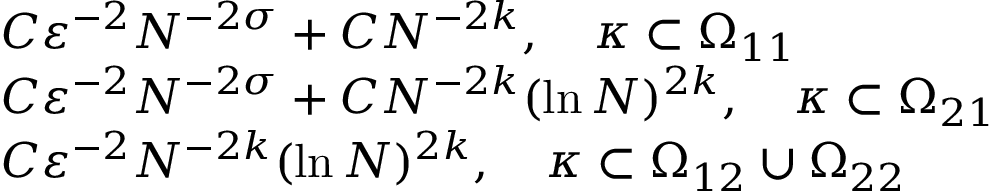<formula> <loc_0><loc_0><loc_500><loc_500>\begin{array} { r l } & { C \varepsilon ^ { - 2 } N ^ { - 2 \sigma } + C N ^ { - 2 k } , \quad \kappa \subset \Omega _ { 1 1 } } \\ & { C \varepsilon ^ { - 2 } N ^ { - 2 \sigma } + C N ^ { - 2 k } ( \ln N ) ^ { 2 k } , \quad \kappa \subset \Omega _ { 2 1 } } \\ & { C \varepsilon ^ { - 2 } N ^ { - 2 k } ( \ln N ) ^ { 2 k } , \quad \kappa \subset \Omega _ { 1 2 } \cup \Omega _ { 2 2 } } \end{array}</formula> 